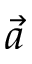<formula> <loc_0><loc_0><loc_500><loc_500>\vec { a }</formula> 